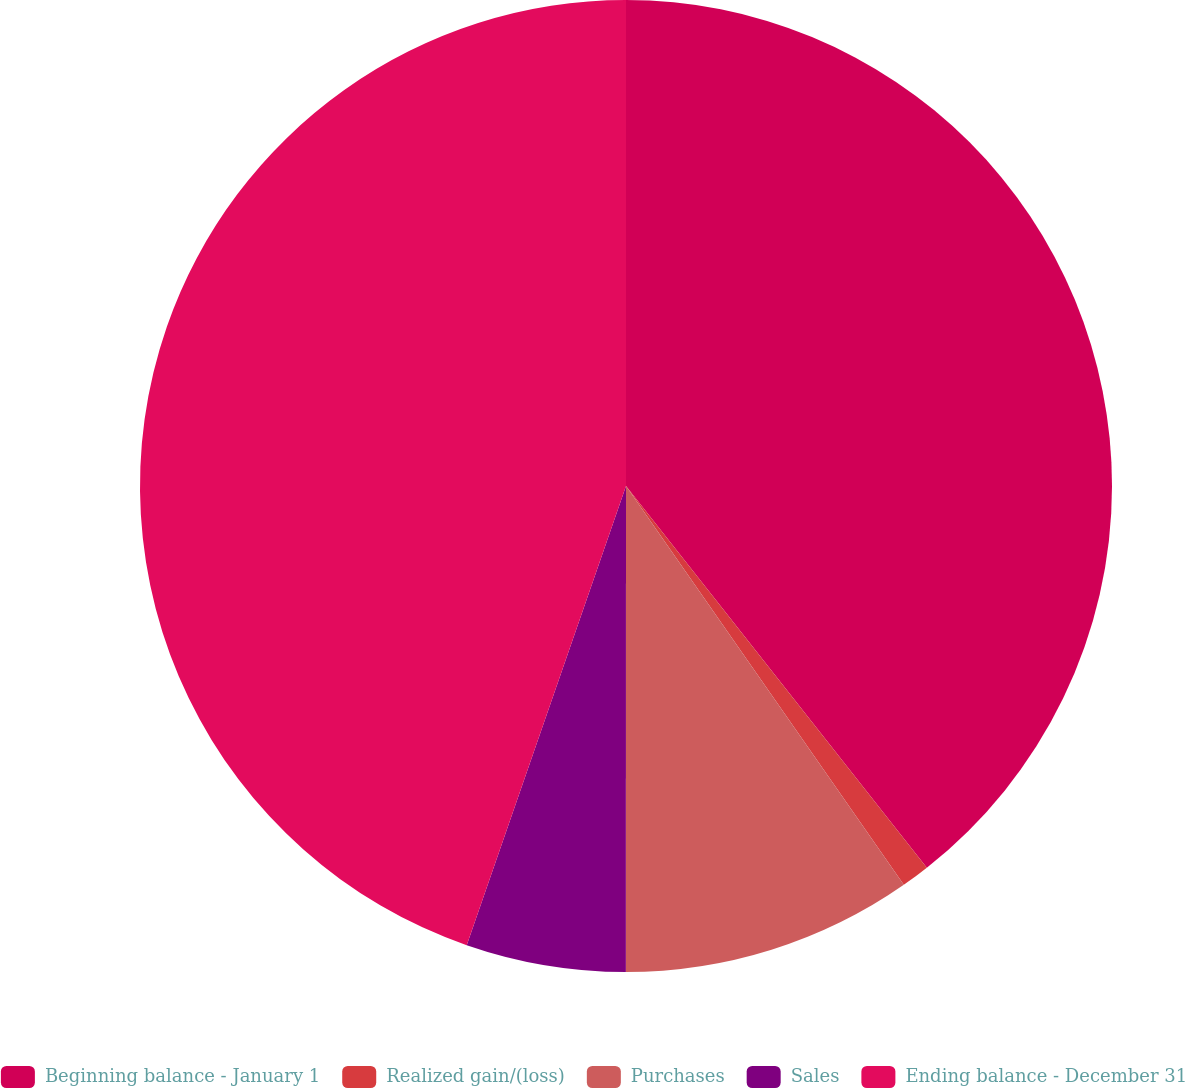Convert chart. <chart><loc_0><loc_0><loc_500><loc_500><pie_chart><fcel>Beginning balance - January 1<fcel>Realized gain/(loss)<fcel>Purchases<fcel>Sales<fcel>Ending balance - December 31<nl><fcel>39.38%<fcel>0.94%<fcel>9.69%<fcel>5.31%<fcel>44.69%<nl></chart> 